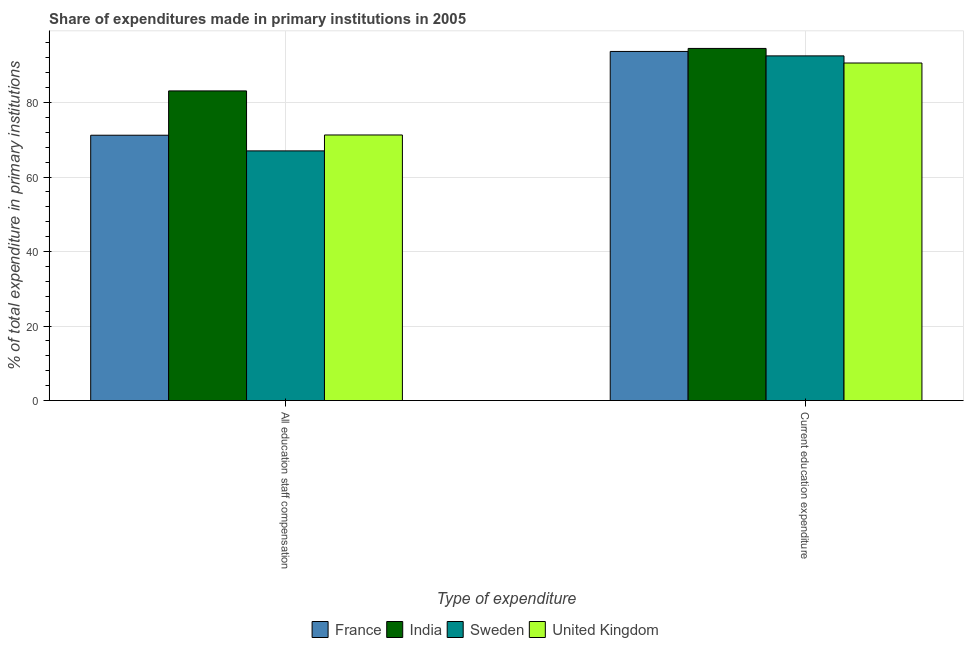How many different coloured bars are there?
Your answer should be compact. 4. How many groups of bars are there?
Your answer should be very brief. 2. Are the number of bars on each tick of the X-axis equal?
Offer a very short reply. Yes. How many bars are there on the 2nd tick from the right?
Keep it short and to the point. 4. What is the label of the 2nd group of bars from the left?
Make the answer very short. Current education expenditure. What is the expenditure in education in France?
Ensure brevity in your answer.  93.72. Across all countries, what is the maximum expenditure in staff compensation?
Offer a very short reply. 83.13. Across all countries, what is the minimum expenditure in staff compensation?
Keep it short and to the point. 67.03. What is the total expenditure in education in the graph?
Your response must be concise. 371.41. What is the difference between the expenditure in staff compensation in Sweden and that in France?
Provide a short and direct response. -4.2. What is the difference between the expenditure in staff compensation in United Kingdom and the expenditure in education in Sweden?
Your answer should be compact. -21.23. What is the average expenditure in staff compensation per country?
Offer a terse response. 73.17. What is the difference between the expenditure in staff compensation and expenditure in education in France?
Offer a terse response. -22.49. What is the ratio of the expenditure in education in France to that in India?
Keep it short and to the point. 0.99. Is the expenditure in staff compensation in Sweden less than that in France?
Ensure brevity in your answer.  Yes. In how many countries, is the expenditure in education greater than the average expenditure in education taken over all countries?
Offer a terse response. 2. What does the 3rd bar from the right in Current education expenditure represents?
Offer a terse response. India. Are all the bars in the graph horizontal?
Make the answer very short. No. How many countries are there in the graph?
Give a very brief answer. 4. What is the difference between two consecutive major ticks on the Y-axis?
Your answer should be very brief. 20. Are the values on the major ticks of Y-axis written in scientific E-notation?
Offer a very short reply. No. Does the graph contain any zero values?
Your answer should be compact. No. Does the graph contain grids?
Ensure brevity in your answer.  Yes. Where does the legend appear in the graph?
Your answer should be very brief. Bottom center. How are the legend labels stacked?
Your response must be concise. Horizontal. What is the title of the graph?
Provide a short and direct response. Share of expenditures made in primary institutions in 2005. Does "Pakistan" appear as one of the legend labels in the graph?
Your answer should be compact. No. What is the label or title of the X-axis?
Your response must be concise. Type of expenditure. What is the label or title of the Y-axis?
Your answer should be very brief. % of total expenditure in primary institutions. What is the % of total expenditure in primary institutions of France in All education staff compensation?
Provide a succinct answer. 71.23. What is the % of total expenditure in primary institutions of India in All education staff compensation?
Keep it short and to the point. 83.13. What is the % of total expenditure in primary institutions of Sweden in All education staff compensation?
Your answer should be very brief. 67.03. What is the % of total expenditure in primary institutions of United Kingdom in All education staff compensation?
Make the answer very short. 71.3. What is the % of total expenditure in primary institutions of France in Current education expenditure?
Ensure brevity in your answer.  93.72. What is the % of total expenditure in primary institutions of India in Current education expenditure?
Provide a succinct answer. 94.53. What is the % of total expenditure in primary institutions in Sweden in Current education expenditure?
Make the answer very short. 92.53. What is the % of total expenditure in primary institutions of United Kingdom in Current education expenditure?
Provide a succinct answer. 90.62. Across all Type of expenditure, what is the maximum % of total expenditure in primary institutions in France?
Offer a terse response. 93.72. Across all Type of expenditure, what is the maximum % of total expenditure in primary institutions of India?
Make the answer very short. 94.53. Across all Type of expenditure, what is the maximum % of total expenditure in primary institutions in Sweden?
Your answer should be very brief. 92.53. Across all Type of expenditure, what is the maximum % of total expenditure in primary institutions of United Kingdom?
Provide a succinct answer. 90.62. Across all Type of expenditure, what is the minimum % of total expenditure in primary institutions in France?
Your answer should be very brief. 71.23. Across all Type of expenditure, what is the minimum % of total expenditure in primary institutions of India?
Your answer should be compact. 83.13. Across all Type of expenditure, what is the minimum % of total expenditure in primary institutions in Sweden?
Offer a terse response. 67.03. Across all Type of expenditure, what is the minimum % of total expenditure in primary institutions in United Kingdom?
Give a very brief answer. 71.3. What is the total % of total expenditure in primary institutions of France in the graph?
Provide a succinct answer. 164.96. What is the total % of total expenditure in primary institutions in India in the graph?
Provide a short and direct response. 177.66. What is the total % of total expenditure in primary institutions in Sweden in the graph?
Give a very brief answer. 159.56. What is the total % of total expenditure in primary institutions of United Kingdom in the graph?
Offer a very short reply. 161.92. What is the difference between the % of total expenditure in primary institutions of France in All education staff compensation and that in Current education expenditure?
Keep it short and to the point. -22.49. What is the difference between the % of total expenditure in primary institutions in India in All education staff compensation and that in Current education expenditure?
Offer a very short reply. -11.4. What is the difference between the % of total expenditure in primary institutions of Sweden in All education staff compensation and that in Current education expenditure?
Offer a very short reply. -25.5. What is the difference between the % of total expenditure in primary institutions of United Kingdom in All education staff compensation and that in Current education expenditure?
Offer a very short reply. -19.32. What is the difference between the % of total expenditure in primary institutions in France in All education staff compensation and the % of total expenditure in primary institutions in India in Current education expenditure?
Your answer should be compact. -23.3. What is the difference between the % of total expenditure in primary institutions in France in All education staff compensation and the % of total expenditure in primary institutions in Sweden in Current education expenditure?
Your answer should be compact. -21.3. What is the difference between the % of total expenditure in primary institutions in France in All education staff compensation and the % of total expenditure in primary institutions in United Kingdom in Current education expenditure?
Keep it short and to the point. -19.39. What is the difference between the % of total expenditure in primary institutions in India in All education staff compensation and the % of total expenditure in primary institutions in Sweden in Current education expenditure?
Offer a very short reply. -9.4. What is the difference between the % of total expenditure in primary institutions in India in All education staff compensation and the % of total expenditure in primary institutions in United Kingdom in Current education expenditure?
Offer a terse response. -7.49. What is the difference between the % of total expenditure in primary institutions in Sweden in All education staff compensation and the % of total expenditure in primary institutions in United Kingdom in Current education expenditure?
Make the answer very short. -23.59. What is the average % of total expenditure in primary institutions of France per Type of expenditure?
Your response must be concise. 82.48. What is the average % of total expenditure in primary institutions of India per Type of expenditure?
Make the answer very short. 88.83. What is the average % of total expenditure in primary institutions of Sweden per Type of expenditure?
Keep it short and to the point. 79.78. What is the average % of total expenditure in primary institutions in United Kingdom per Type of expenditure?
Your response must be concise. 80.96. What is the difference between the % of total expenditure in primary institutions of France and % of total expenditure in primary institutions of India in All education staff compensation?
Your answer should be compact. -11.9. What is the difference between the % of total expenditure in primary institutions in France and % of total expenditure in primary institutions in Sweden in All education staff compensation?
Make the answer very short. 4.2. What is the difference between the % of total expenditure in primary institutions in France and % of total expenditure in primary institutions in United Kingdom in All education staff compensation?
Offer a terse response. -0.07. What is the difference between the % of total expenditure in primary institutions of India and % of total expenditure in primary institutions of Sweden in All education staff compensation?
Offer a terse response. 16.1. What is the difference between the % of total expenditure in primary institutions in India and % of total expenditure in primary institutions in United Kingdom in All education staff compensation?
Provide a short and direct response. 11.83. What is the difference between the % of total expenditure in primary institutions in Sweden and % of total expenditure in primary institutions in United Kingdom in All education staff compensation?
Offer a very short reply. -4.27. What is the difference between the % of total expenditure in primary institutions in France and % of total expenditure in primary institutions in India in Current education expenditure?
Your response must be concise. -0.81. What is the difference between the % of total expenditure in primary institutions of France and % of total expenditure in primary institutions of Sweden in Current education expenditure?
Your answer should be compact. 1.19. What is the difference between the % of total expenditure in primary institutions in France and % of total expenditure in primary institutions in United Kingdom in Current education expenditure?
Your answer should be very brief. 3.1. What is the difference between the % of total expenditure in primary institutions of India and % of total expenditure in primary institutions of United Kingdom in Current education expenditure?
Offer a very short reply. 3.91. What is the difference between the % of total expenditure in primary institutions in Sweden and % of total expenditure in primary institutions in United Kingdom in Current education expenditure?
Your answer should be compact. 1.91. What is the ratio of the % of total expenditure in primary institutions of France in All education staff compensation to that in Current education expenditure?
Your answer should be very brief. 0.76. What is the ratio of the % of total expenditure in primary institutions in India in All education staff compensation to that in Current education expenditure?
Provide a succinct answer. 0.88. What is the ratio of the % of total expenditure in primary institutions in Sweden in All education staff compensation to that in Current education expenditure?
Keep it short and to the point. 0.72. What is the ratio of the % of total expenditure in primary institutions of United Kingdom in All education staff compensation to that in Current education expenditure?
Give a very brief answer. 0.79. What is the difference between the highest and the second highest % of total expenditure in primary institutions of France?
Provide a short and direct response. 22.49. What is the difference between the highest and the second highest % of total expenditure in primary institutions in India?
Ensure brevity in your answer.  11.4. What is the difference between the highest and the second highest % of total expenditure in primary institutions in Sweden?
Make the answer very short. 25.5. What is the difference between the highest and the second highest % of total expenditure in primary institutions in United Kingdom?
Your answer should be very brief. 19.32. What is the difference between the highest and the lowest % of total expenditure in primary institutions of France?
Your response must be concise. 22.49. What is the difference between the highest and the lowest % of total expenditure in primary institutions in India?
Offer a very short reply. 11.4. What is the difference between the highest and the lowest % of total expenditure in primary institutions in Sweden?
Ensure brevity in your answer.  25.5. What is the difference between the highest and the lowest % of total expenditure in primary institutions of United Kingdom?
Make the answer very short. 19.32. 